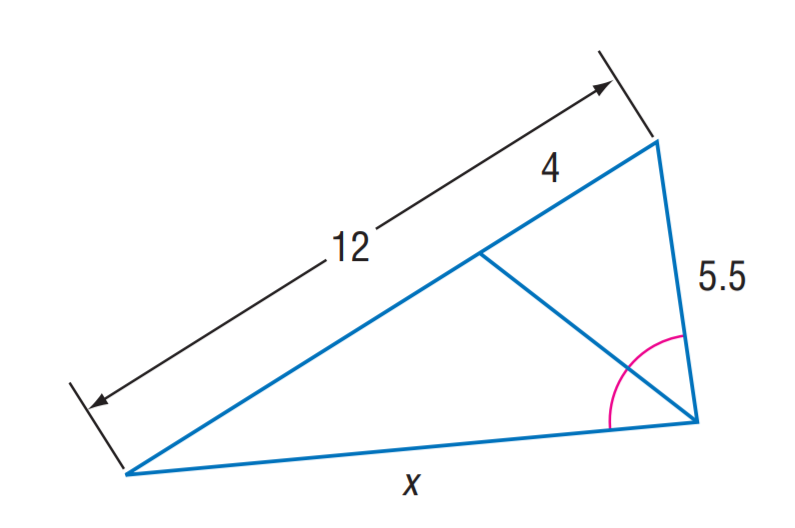Question: Find x.
Choices:
A. 5.5
B. 11
C. 16.5
D. 22
Answer with the letter. Answer: B 